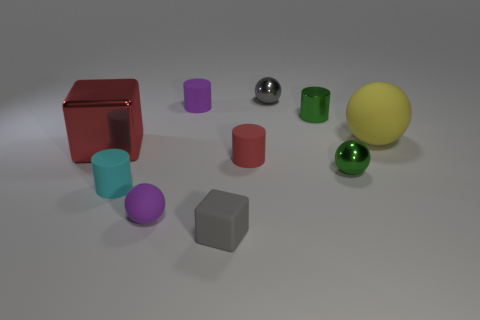There is a sphere that is both in front of the gray metallic thing and behind the green metal sphere; what is its size?
Offer a terse response. Large. Are there any small spheres that have the same color as the small matte block?
Your answer should be very brief. Yes. What is the color of the tiny sphere that is on the right side of the gray object that is behind the cyan thing?
Provide a succinct answer. Green. Is the number of big yellow matte spheres that are behind the large ball less than the number of tiny purple rubber things that are in front of the large red shiny object?
Offer a terse response. Yes. Do the red cylinder and the red shiny cube have the same size?
Your answer should be compact. No. What shape is the shiny object that is both in front of the large yellow matte sphere and to the right of the big red shiny block?
Provide a succinct answer. Sphere. How many tiny purple balls are the same material as the purple cylinder?
Offer a terse response. 1. There is a small rubber cylinder that is behind the large red thing; what number of small shiny balls are in front of it?
Offer a terse response. 1. What is the shape of the rubber object behind the large yellow ball that is right of the metal thing on the left side of the tiny rubber block?
Keep it short and to the point. Cylinder. There is a metal ball that is the same color as the shiny cylinder; what is its size?
Your answer should be compact. Small. 